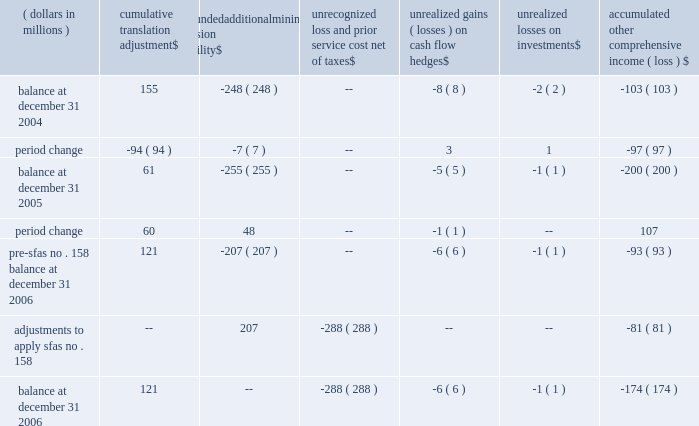Eastman notes to the audited consolidated financial statements accumulated other comprehensive income ( loss ) ( dollars in millions ) cumulative translation adjustment unfunded additional minimum pension liability unrecognized loss and prior service cost , net of unrealized gains ( losses ) on cash flow hedges unrealized losses on investments accumulated comprehensive income ( loss ) balance at december 31 , 2004 155 ( 248 ) -- ( 8 ) ( 2 ) ( 103 ) .
Pre-sfas no .
158 balance at december 31 , 2006 121 ( 207 ) -- ( 6 ) ( 1 ) ( 93 ) adjustments to apply sfas no .
158 -- 207 ( 288 ) -- -- ( 81 ) balance at december 31 , 2006 121 -- ( 288 ) ( 6 ) ( 1 ) ( 174 ) except for cumulative translation adjustment , amounts of other comprehensive income ( loss ) are presented net of applicable taxes .
Because cumulative translation adjustment is considered a component of permanently invested , unremitted earnings of subsidiaries outside the united states , no taxes are provided on such amounts .
15 .
Share-based compensation plans and awards 2002 omnibus long-term compensation plan eastman's 2002 omnibus long-term compensation plan provides for grants to employees of nonqualified stock options , incentive stock options , tandem and freestanding stock appreciation rights ( 201csar 2019s 201d ) , performance shares and various other stock and stock-based awards .
The 2002 omnibus plan provides that options can be granted through may 2 , 2007 , for the purchase of eastman common stock at an option price not less than 100 percent of the per share fair market value on the date of the stock option's grant .
There is a maximum of 7.5 million shares of common stock available for option grants and other awards during the term of the 2002 omnibus plan .
Director long-term compensation plan eastman's 2002 director long-term compensation plan provides for grants of nonqualified stock options and restricted shares to nonemployee members of the board of directors .
Shares of restricted stock are granted upon the first day of the directors' initial term of service and nonqualified stock options and shares of restricted stock are granted each year following the annual meeting of stockholders .
The 2002 director plan provides that options can be granted through the later of may 1 , 2007 , or the date of the annual meeting of stockholders in 2007 for the purchase of eastman common stock at an option price not less than the stock's fair market value on the date of the grant. .
What is the percent change in cumulative translation adjustment between 2005 and 2006? 
Computations: ((121 - 61) / 61)
Answer: 0.98361. Eastman notes to the audited consolidated financial statements accumulated other comprehensive income ( loss ) ( dollars in millions ) cumulative translation adjustment unfunded additional minimum pension liability unrecognized loss and prior service cost , net of unrealized gains ( losses ) on cash flow hedges unrealized losses on investments accumulated comprehensive income ( loss ) balance at december 31 , 2004 155 ( 248 ) -- ( 8 ) ( 2 ) ( 103 ) .
Pre-sfas no .
158 balance at december 31 , 2006 121 ( 207 ) -- ( 6 ) ( 1 ) ( 93 ) adjustments to apply sfas no .
158 -- 207 ( 288 ) -- -- ( 81 ) balance at december 31 , 2006 121 -- ( 288 ) ( 6 ) ( 1 ) ( 174 ) except for cumulative translation adjustment , amounts of other comprehensive income ( loss ) are presented net of applicable taxes .
Because cumulative translation adjustment is considered a component of permanently invested , unremitted earnings of subsidiaries outside the united states , no taxes are provided on such amounts .
15 .
Share-based compensation plans and awards 2002 omnibus long-term compensation plan eastman's 2002 omnibus long-term compensation plan provides for grants to employees of nonqualified stock options , incentive stock options , tandem and freestanding stock appreciation rights ( 201csar 2019s 201d ) , performance shares and various other stock and stock-based awards .
The 2002 omnibus plan provides that options can be granted through may 2 , 2007 , for the purchase of eastman common stock at an option price not less than 100 percent of the per share fair market value on the date of the stock option's grant .
There is a maximum of 7.5 million shares of common stock available for option grants and other awards during the term of the 2002 omnibus plan .
Director long-term compensation plan eastman's 2002 director long-term compensation plan provides for grants of nonqualified stock options and restricted shares to nonemployee members of the board of directors .
Shares of restricted stock are granted upon the first day of the directors' initial term of service and nonqualified stock options and shares of restricted stock are granted each year following the annual meeting of stockholders .
The 2002 director plan provides that options can be granted through the later of may 1 , 2007 , or the date of the annual meeting of stockholders in 2007 for the purchase of eastman common stock at an option price not less than the stock's fair market value on the date of the grant. .
What is the percent change in cumulative translation adjustment between 2004 and 2006? 
Computations: ((121 - 155) / 155)
Answer: -0.21935. 